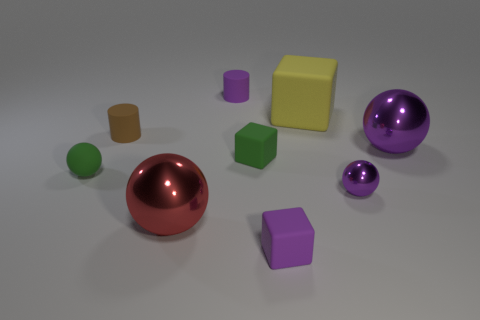Is the number of big purple metal objects to the left of the red shiny object the same as the number of green rubber cubes that are behind the large yellow matte object?
Offer a terse response. Yes. Do the purple rubber thing that is in front of the tiny purple cylinder and the green thing that is right of the large red metallic ball have the same size?
Your answer should be very brief. Yes. What shape is the matte object in front of the large ball in front of the tiny object that is right of the large yellow thing?
Offer a very short reply. Cube. Is there any other thing that has the same material as the tiny brown object?
Your response must be concise. Yes. There is a red metal thing that is the same shape as the big purple thing; what is its size?
Make the answer very short. Large. There is a tiny thing that is both right of the small green ball and left of the large red metallic sphere; what is its color?
Keep it short and to the point. Brown. Do the tiny green sphere and the purple thing left of the purple block have the same material?
Your response must be concise. Yes. Is the number of green rubber objects in front of the large purple metal ball less than the number of red cylinders?
Provide a succinct answer. No. How many other objects are the same shape as the large purple shiny object?
Offer a terse response. 3. Is there any other thing that is the same color as the tiny rubber ball?
Your answer should be compact. Yes. 